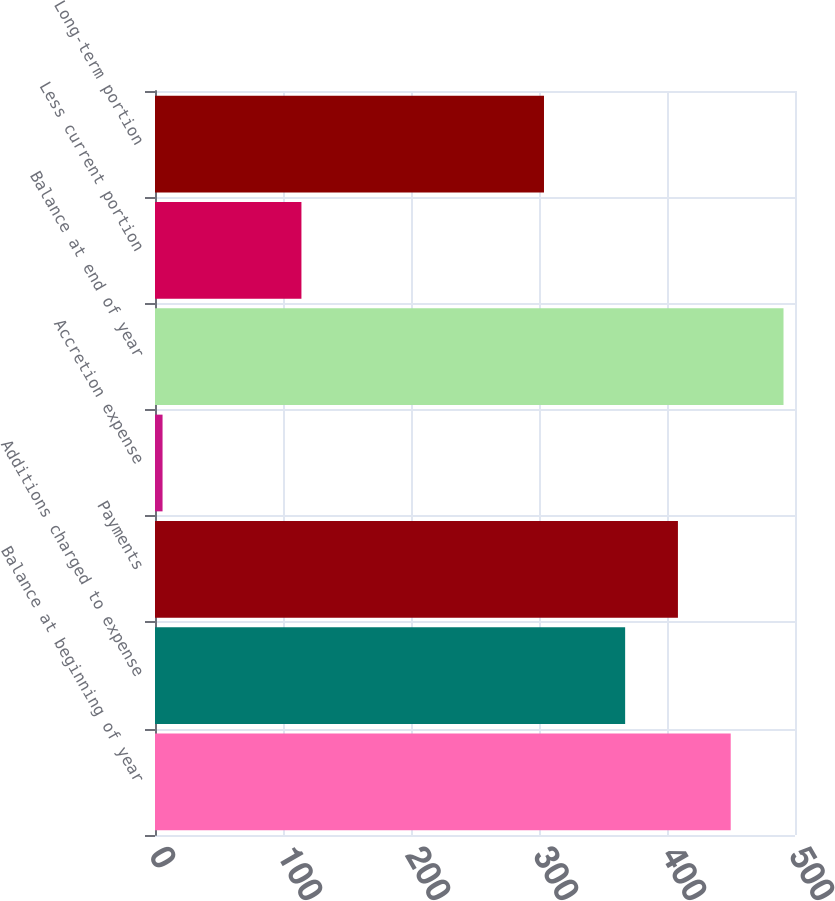Convert chart. <chart><loc_0><loc_0><loc_500><loc_500><bar_chart><fcel>Balance at beginning of year<fcel>Additions charged to expense<fcel>Payments<fcel>Accretion expense<fcel>Balance at end of year<fcel>Less current portion<fcel>Long-term portion<nl><fcel>449.78<fcel>367.3<fcel>408.54<fcel>5.9<fcel>491.02<fcel>114.4<fcel>303.9<nl></chart> 